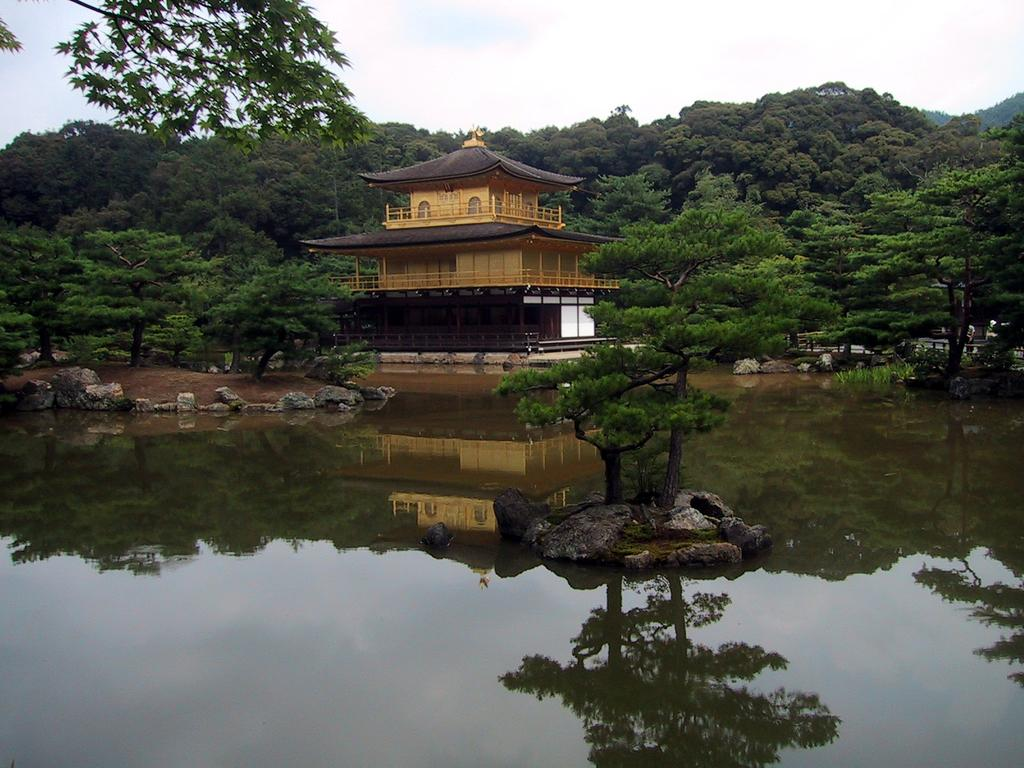What type of structure is present in the image? There is a building in the image. What other natural elements can be seen in the image? There are trees and water visible in the image. What is visible in the background of the image? The sky is visible in the background of the image. How many eyes can be seen on the rabbit in the image? There is no rabbit present in the image, so it is not possible to determine the number of eyes on a rabbit. 